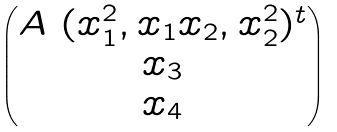Convert formula to latex. <formula><loc_0><loc_0><loc_500><loc_500>\begin{pmatrix} A \ ( x _ { 1 } ^ { 2 } , x _ { 1 } x _ { 2 } , x _ { 2 } ^ { 2 } ) ^ { t } \\ x _ { 3 } \\ x _ { 4 } \end{pmatrix}</formula> 